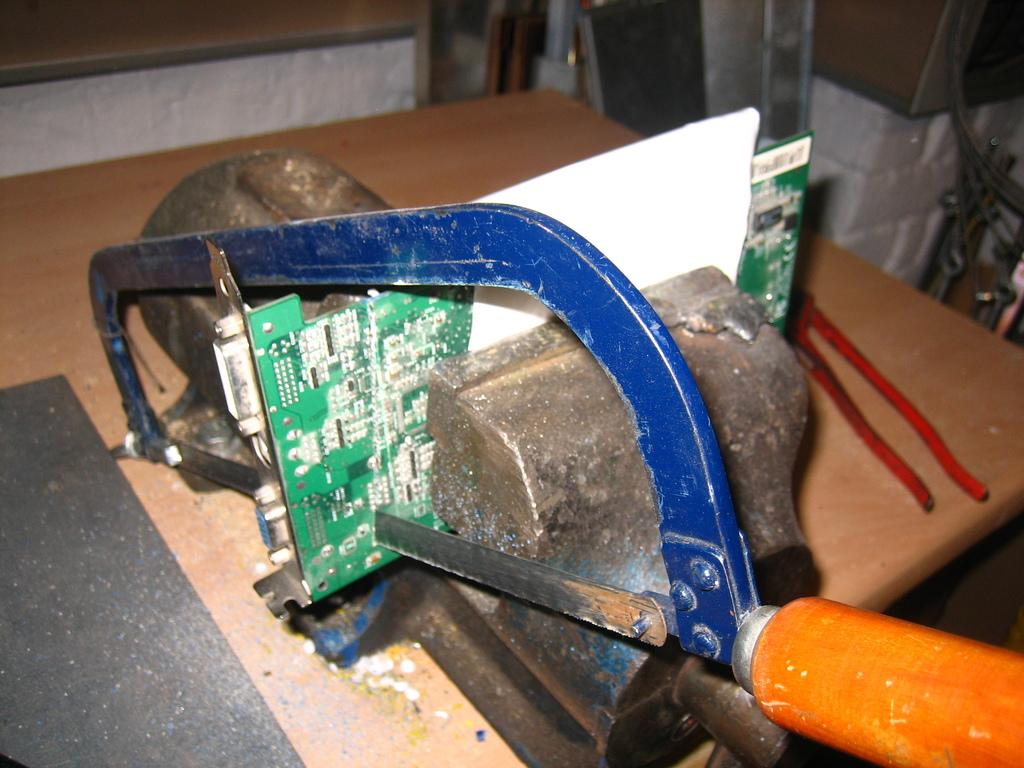What tool is being used in the image? There is a mini saw in the image. What is the mini saw doing in the image? The mini saw is cutting an object. What other object is present in the image related to the cutting process? There is a cutting player in the image. Where are all these objects located? All the mentioned objects are on a table. What type of winter clothing is being worn by the mini saw in the image? There is no winter clothing or any indication of winter in the image, as it features a mini saw cutting an object and a cutting player. 